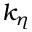<formula> <loc_0><loc_0><loc_500><loc_500>k _ { \eta }</formula> 